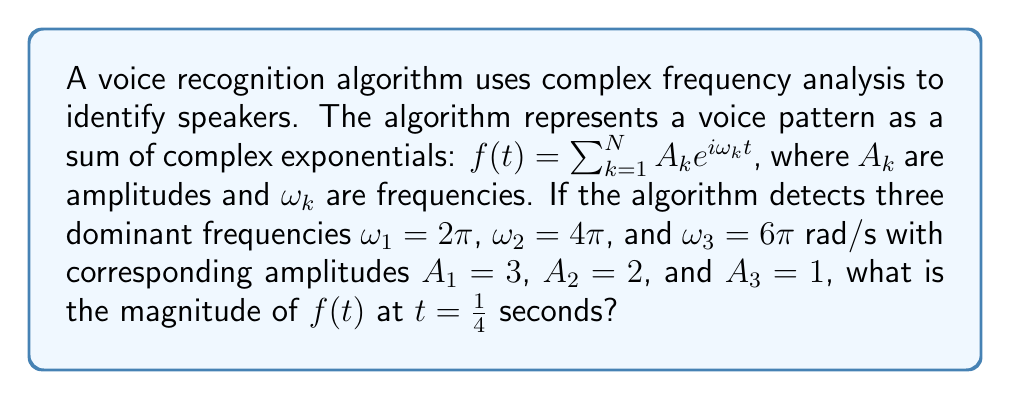Show me your answer to this math problem. To solve this problem, we'll follow these steps:

1) The given voice pattern function is:
   $f(t) = 3e^{i2\pi t} + 2e^{i4\pi t} + e^{i6\pi t}$

2) We need to evaluate this at $t = \frac{1}{4}$:
   $f(\frac{1}{4}) = 3e^{i2\pi (\frac{1}{4})} + 2e^{i4\pi (\frac{1}{4})} + e^{i6\pi (\frac{1}{4})}$

3) Simplify the exponents:
   $f(\frac{1}{4}) = 3e^{i\frac{\pi}{2}} + 2e^{i\pi} + e^{i\frac{3\pi}{2}}$

4) Recall Euler's formula: $e^{i\theta} = \cos\theta + i\sin\theta$
   $e^{i\frac{\pi}{2}} = i$
   $e^{i\pi} = -1$
   $e^{i\frac{3\pi}{2}} = -i$

5) Substitute these values:
   $f(\frac{1}{4}) = 3i + 2(-1) + (-i) = 3i - 2 - i = 2i - 2$

6) To find the magnitude, we use the formula $|a+bi| = \sqrt{a^2 + b^2}$:
   $|f(\frac{1}{4})| = |2i - 2| = \sqrt{(-2)^2 + 2^2} = \sqrt{8}$

7) Simplify:
   $|f(\frac{1}{4})| = 2\sqrt{2}$
Answer: $2\sqrt{2}$ 